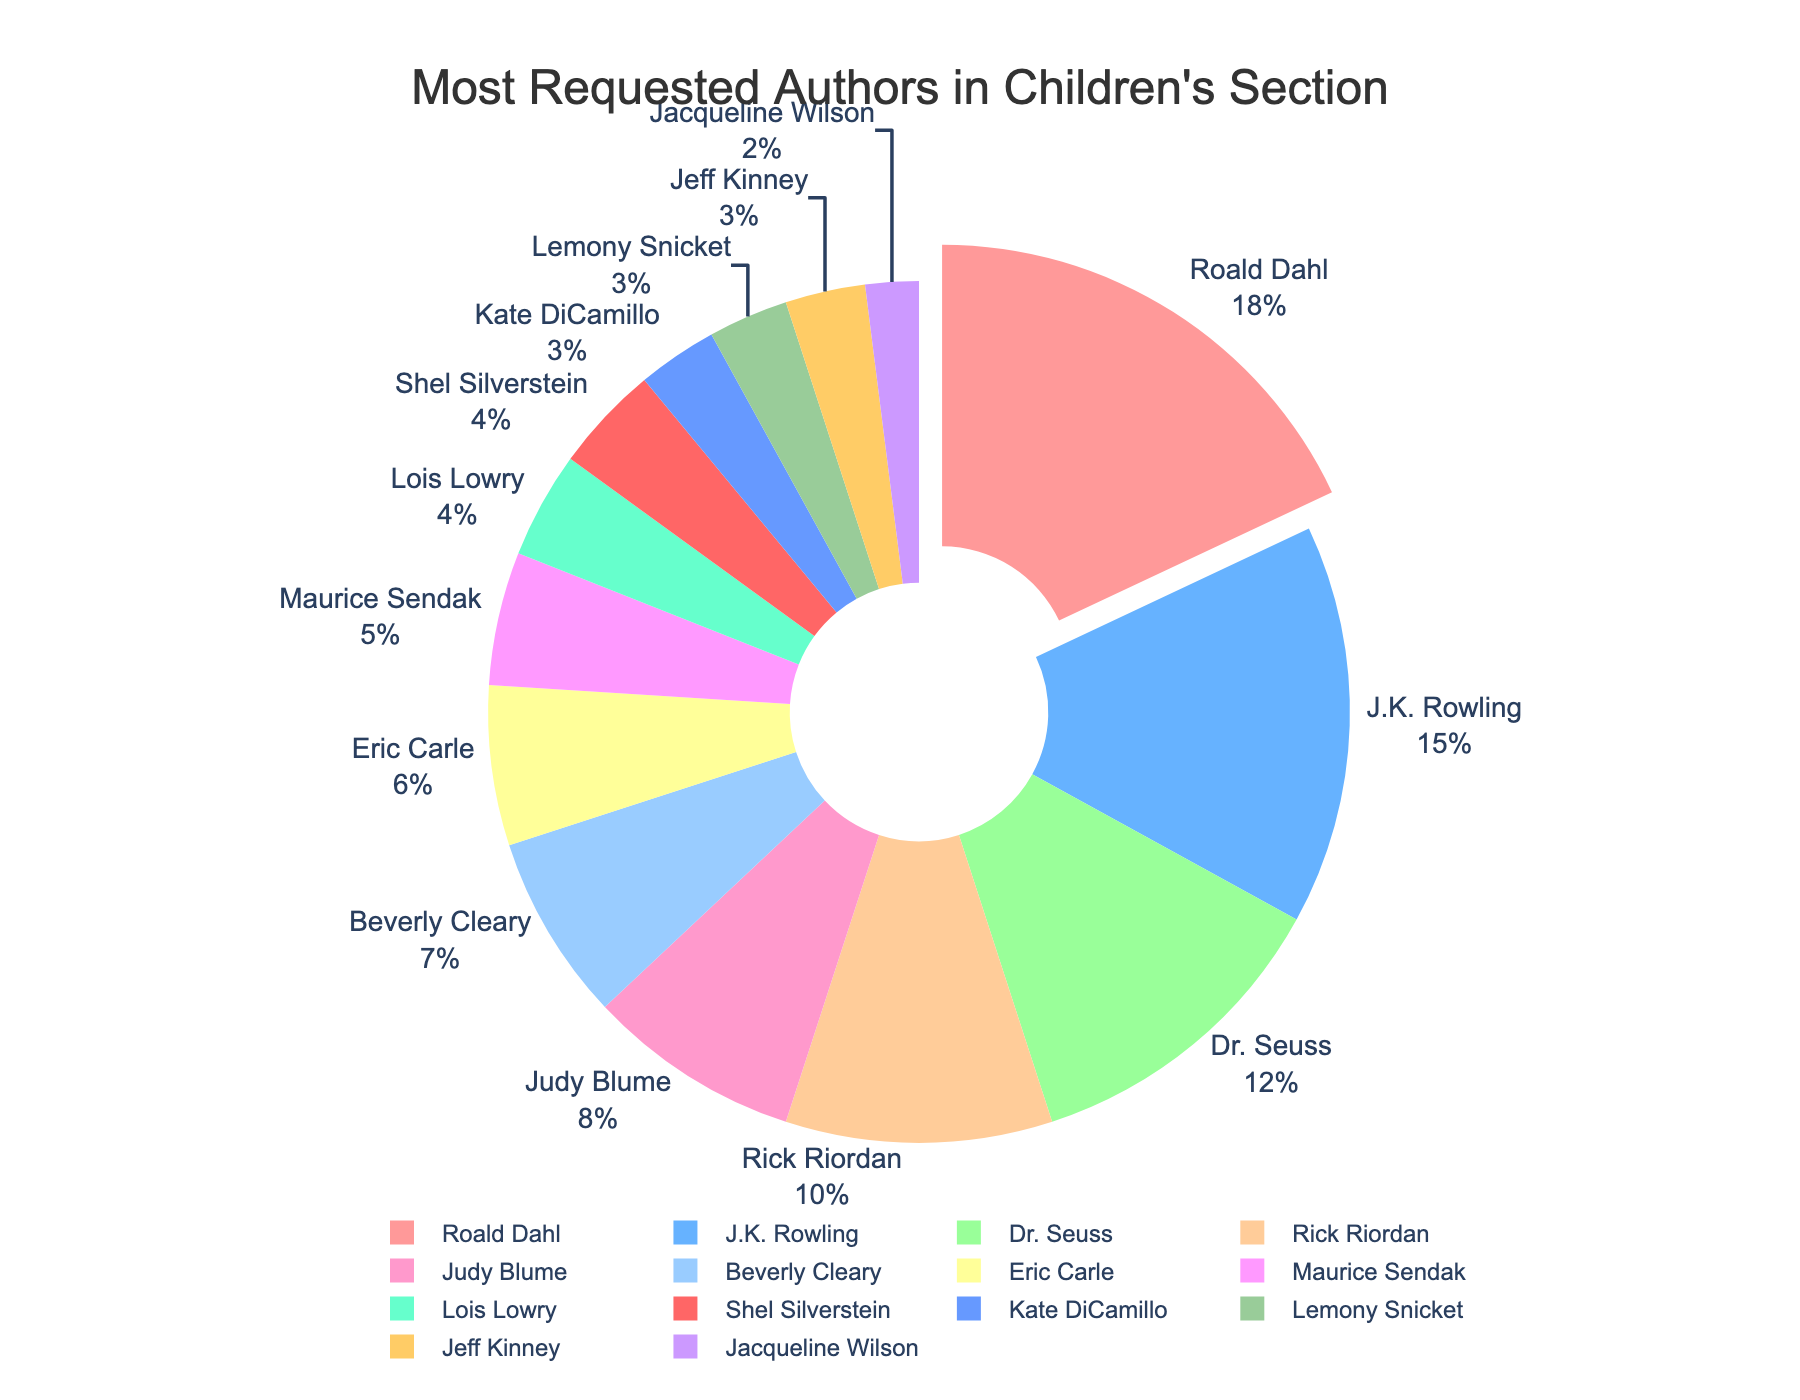What's the most requested author? To find the most requested author, look at the section of the pie chart that is pulled out and has the largest percentage. It is labeled "Roald Dahl" with 18%.
Answer: Roald Dahl What is the combined percentage of requests for J.K. Rowling and Dr. Seuss? Sum the percentages for J.K. Rowling (15%) and Dr. Seuss (12%). 15 + 12 = 27.
Answer: 27% Which author has the smallest percentage of requests? Look at the pie chart for the smallest segment. It is labeled "Jacqueline Wilson" with 2%.
Answer: Jacqueline Wilson How many authors have request percentages of 10% or higher? Count the segments in the pie chart with percentages of 10% or higher: Roald Dahl (18%), J.K. Rowling (15%), Dr. Seuss (12%), Rick Riordan (10%).
Answer: 4 authors What is the total percentage of requests for authors with less than 5%? Sum the percentages for Maurice Sendak (5%), Lois Lowry (4%), Shel Silverstein (4%), Kate DiCamillo (3%), Lemony Snicket (3%), Jeff Kinney (3%), Jacqueline Wilson (2%). 5 + 4 + 4 + 3 + 3 + 3 + 2 = 24.
Answer: 24% Which author has 10% of the requests? Look for the segment labeled with 10%. It is Rick Riordan.
Answer: Rick Riordan What is the difference in request percentage between Roald Dahl and Beverly Cleary? Subtract Beverly Cleary's percentage (7%) from Roald Dahl's percentage (18%). 18 - 7 = 11.
Answer: 11% Who has more requests: Judy Blume or Eric Carle, and by how much? Judy Blume has 8% and Eric Carle has 6%. Subtract Eric Carle's percentage from Judy Blume's. 8 - 6 = 2.
Answer: Judy Blume by 2% What are the three authors with the lowest request percentages? Identify the three smallest segments: Jacqueline Wilson (2%), Jeff Kinney (3%), and Lemony Snicket (3%).
Answer: Jacqueline Wilson, Jeff Kinney, and Lemony Snicket 